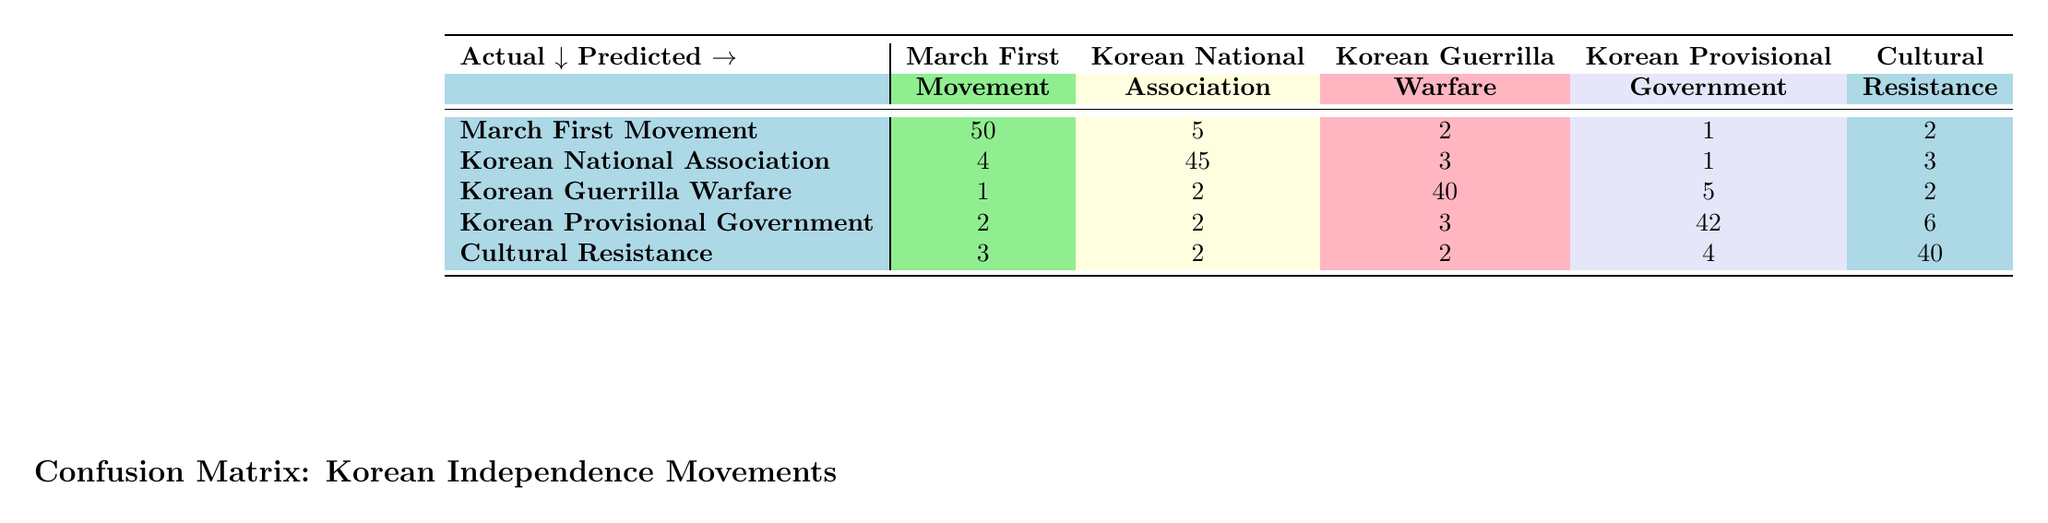What is the number of true instances that were predicted as "March First Movement"? According to the table, there are 50 true instances of the "March First Movement" that were correctly predicted under the same category.
Answer: 50 What percentage of the predictions for "Korean Guerrilla Warfare" were correct? There are 40 instances of "Korean Guerrilla Warfare" predicted correctly, and the total instances predicted for that movement is 40 + 1 + 2 + 5 + 2 = 50. Therefore, the percentage is (40/50) * 100 = 80%.
Answer: 80% Is it true that "Cultural Resistance" was predicted more accurately than the "Korean National Association"? The true instances predicted correctly for "Cultural Resistance" is 40, while for "Korean National Association" it is 45. Since 45 > 40, it is false that "Cultural Resistance" was predicted more accurately.
Answer: No Which resistance movement has the highest number of misclassifications? To determine this, we can sum the off-diagonal values for each category. For "March First Movement", the misclassifications total to (5 + 2 + 1 + 2) = 10. For "Korean National Association", it's (4 + 3 + 1 + 3) = 11. For "Korean Guerrilla Warfare", it's (1 + 2 + 5 + 2) = 10. For "Korean Provisional Government", it's (2 + 2 + 3 + 6) = 13. For "Cultural Resistance", it's (3 + 2 + 2 + 4) = 11. Therefore, "Korean Provisional Government" has the highest misclassifications with 13.
Answer: Korean Provisional Government How many total instances were there for the "Korean Provisional Government"? The total instances predicted for the "Korean Provisional Government" can be calculated by summing all the values in its row: 2 + 2 + 3 + 42 + 6 = 55.
Answer: 55 What is the confusion count of instances incorrectly predicted as "March First Movement"? The confusion count for "March First Movement" is the sum of instances predicted as "Korean National Association", "Korean Guerrilla Warfare", "Korean Provisional Government", and "Cultural Resistance". Thus, the count is 5 + 2 + 1 + 2 = 10.
Answer: 10 